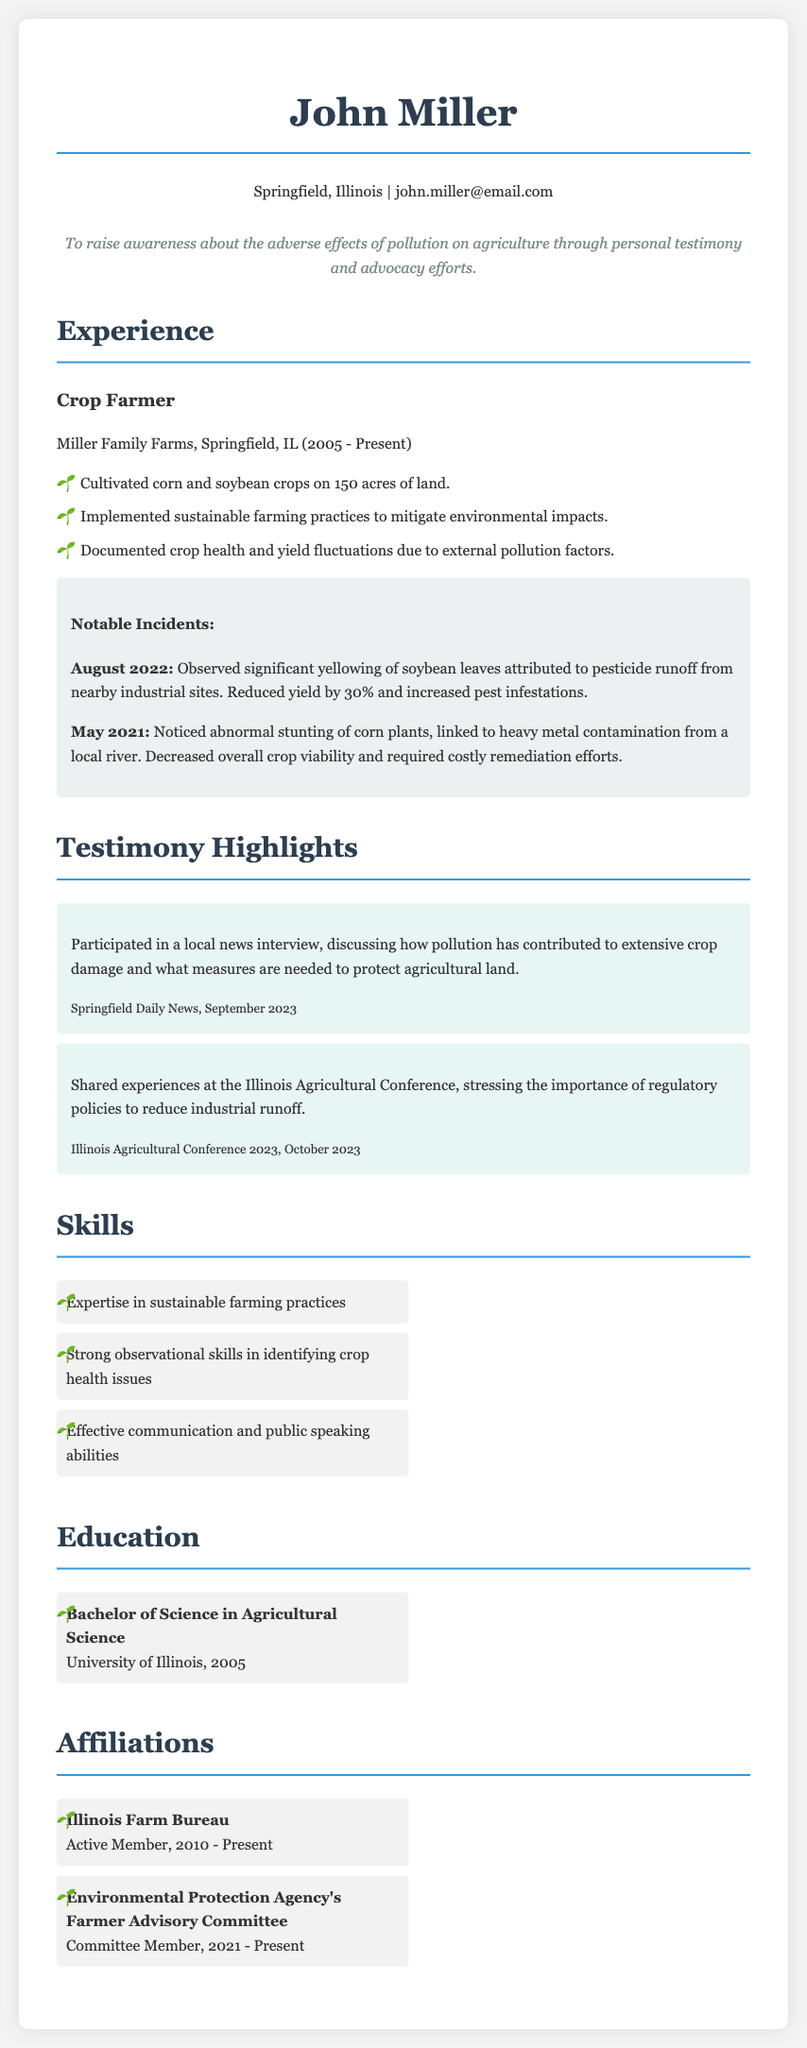What is the name of the farmer? The name of the farmer is listed at the top of the document as John Miller.
Answer: John Miller What year did John Miller graduate? The education section states that he graduated in 2005.
Answer: 2005 How many acres does Miller Family Farms cultivate? The experience section mentions cultivation on 150 acres of land.
Answer: 150 acres What was the yield reduction percentage for soybeans in August 2022? The document notes a reduced yield by 30% due to pollution effects.
Answer: 30% What event did John Miller speak at in October 2023? The highlights section provides that he shared experiences at the Illinois Agricultural Conference.
Answer: Illinois Agricultural Conference What type of membership does John Miller have with the Illinois Farm Bureau? The affiliations section states he is an active member.
Answer: Active Member In which month and year was the significant yellowing of soybean leaves observed? The document specifies August 2022 for this incident.
Answer: August 2022 What committee is John Miller a member of? The affiliations section mentions his role in the Environmental Protection Agency's Farmer Advisory Committee.
Answer: Farmer Advisory Committee What is John Miller's objective as stated in the document? The objective section outlines his aim to raise awareness about pollution effects on agriculture.
Answer: Raise awareness about pollution effects on agriculture 